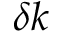<formula> <loc_0><loc_0><loc_500><loc_500>\delta k</formula> 